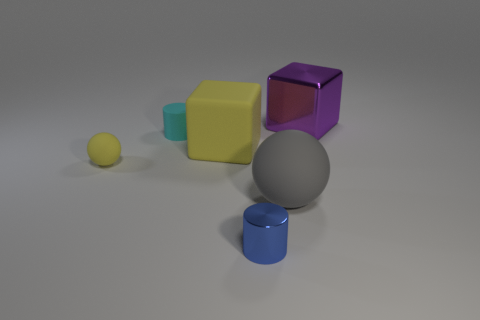Do the small sphere and the big matte cube have the same color? yes 